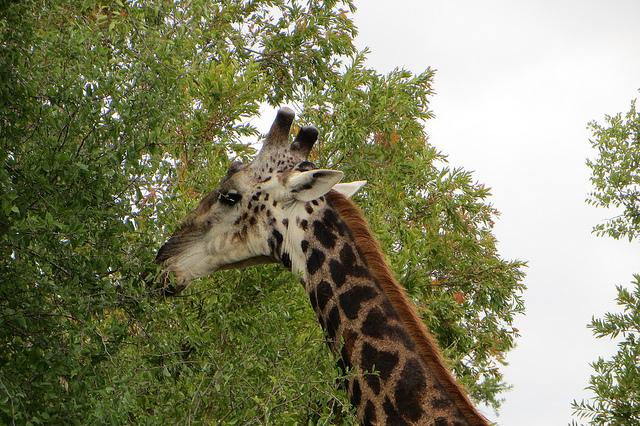Which way is the giraffe facing?
Concise answer only. Left. What part of the animal is shown in this picture?
Concise answer only. Head. Are the giraffes wild?
Give a very brief answer. Yes. What animal is shown?
Be succinct. Giraffe. What is in the animal's mouth?
Answer briefly. Leaves. Can you see the animals tongue?
Concise answer only. No. 